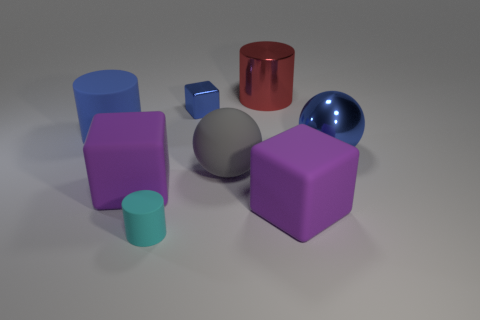Is there another large gray object of the same shape as the gray object?
Provide a succinct answer. No. What shape is the blue matte object that is the same size as the red shiny object?
Provide a short and direct response. Cylinder. The purple thing that is on the left side of the tiny rubber cylinder has what shape?
Your response must be concise. Cube. Are there fewer big matte objects that are in front of the gray sphere than big gray objects on the left side of the red metal object?
Offer a very short reply. No. Do the blue cylinder and the rubber cube that is on the left side of the large gray ball have the same size?
Offer a very short reply. Yes. How many rubber cylinders are the same size as the shiny cylinder?
Provide a succinct answer. 1. There is a sphere that is made of the same material as the red object; what is its color?
Ensure brevity in your answer.  Blue. Is the number of large purple blocks greater than the number of big red metallic objects?
Keep it short and to the point. Yes. Are the blue cube and the small cylinder made of the same material?
Provide a succinct answer. No. What shape is the large blue thing that is made of the same material as the tiny blue block?
Your answer should be very brief. Sphere. 